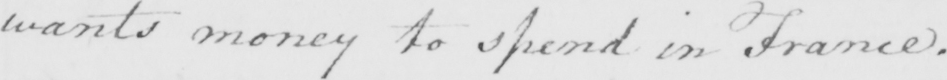Please transcribe the handwritten text in this image. wants money to spend in France . 